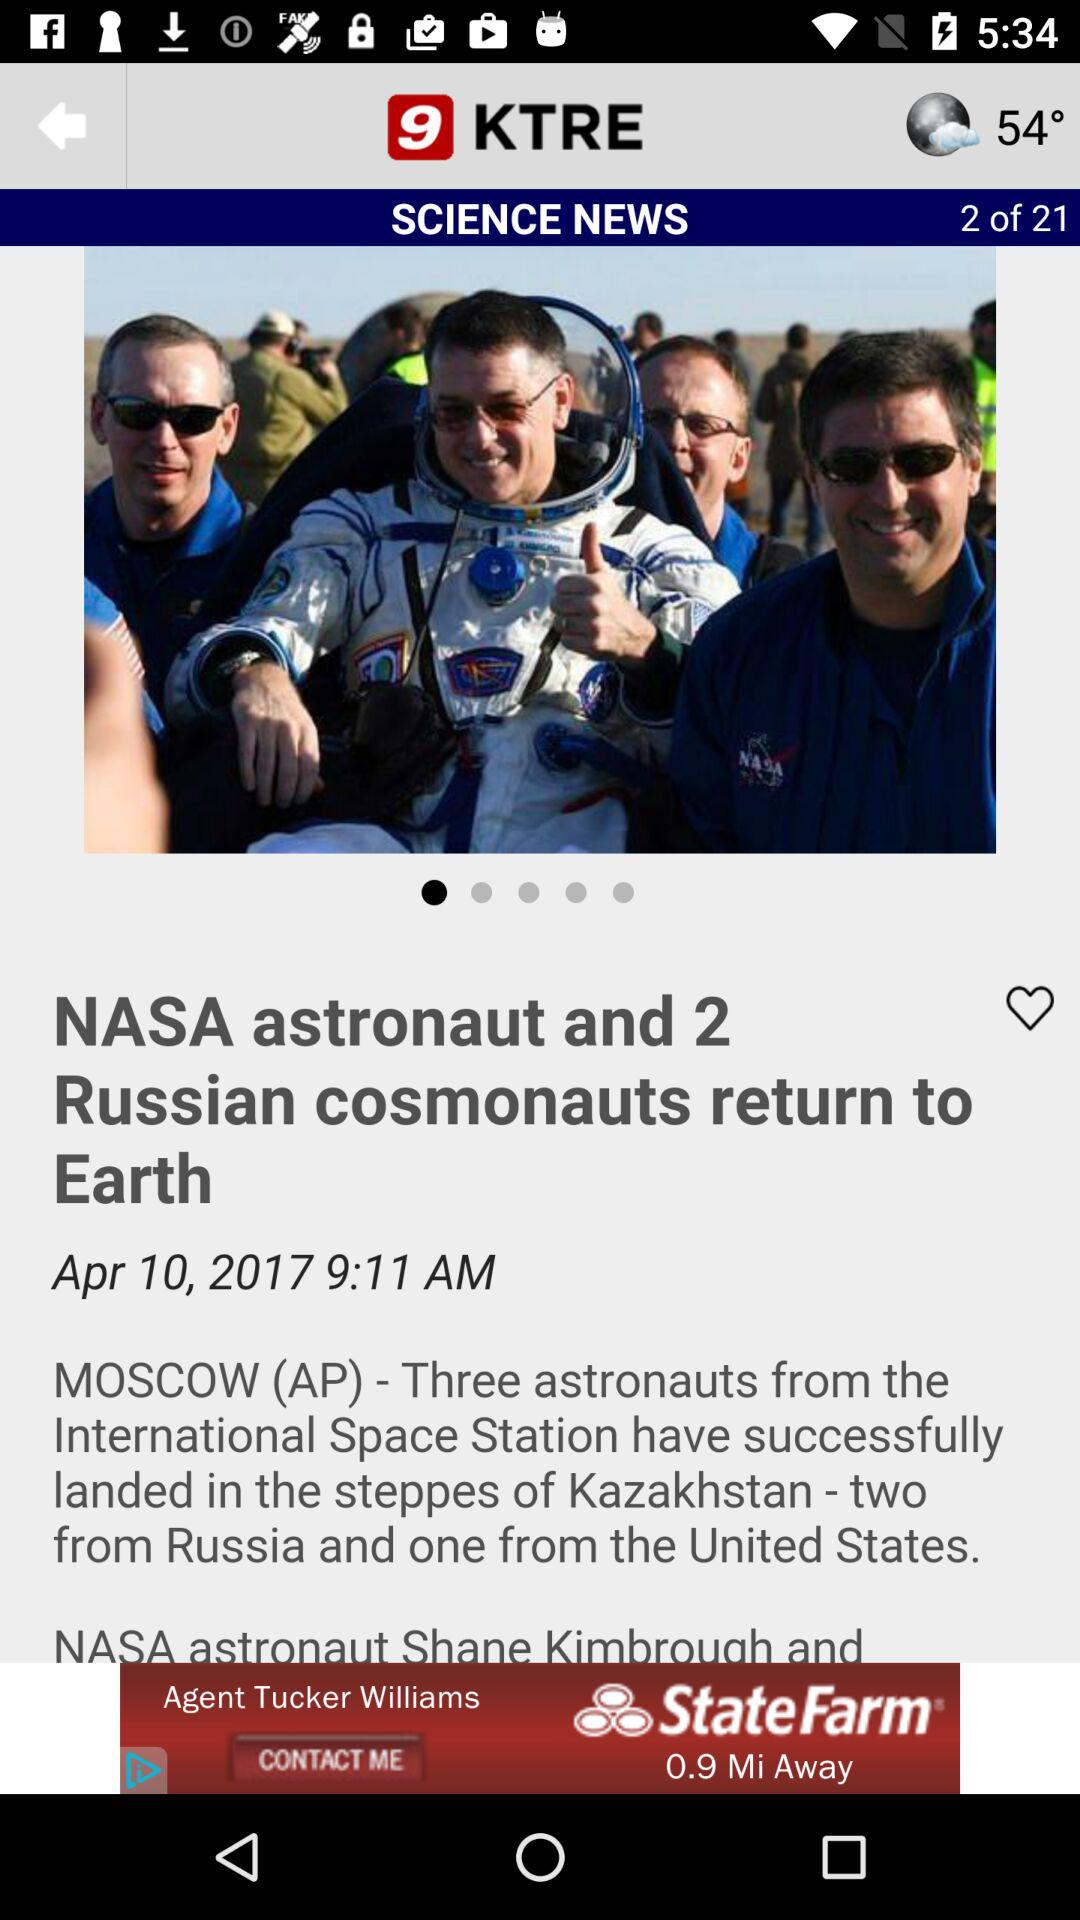What is the total number of news? The total number of news is 21. 